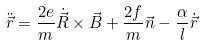Convert formula to latex. <formula><loc_0><loc_0><loc_500><loc_500>\ddot { \vec { r } } = \frac { 2 e } { m } \dot { \vec { R } } \times \vec { B } + \frac { 2 f } { m } \vec { n } - \frac { \alpha } { l } \dot { \vec { r } }</formula> 